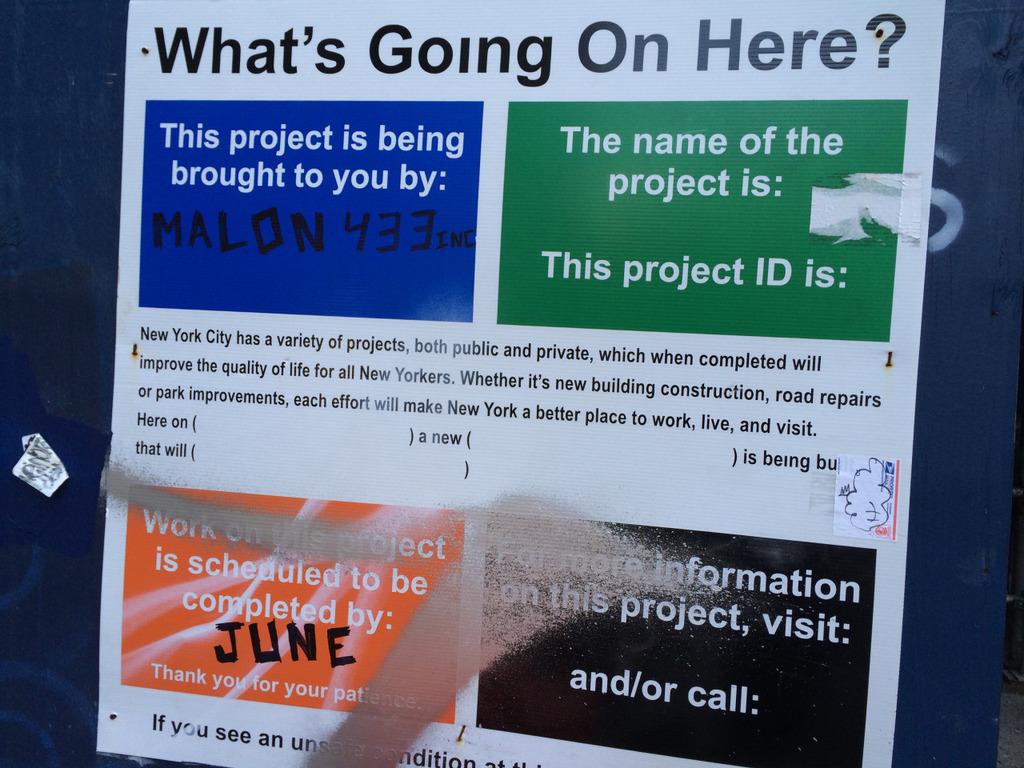What is the month on this?
Your answer should be very brief. June. 